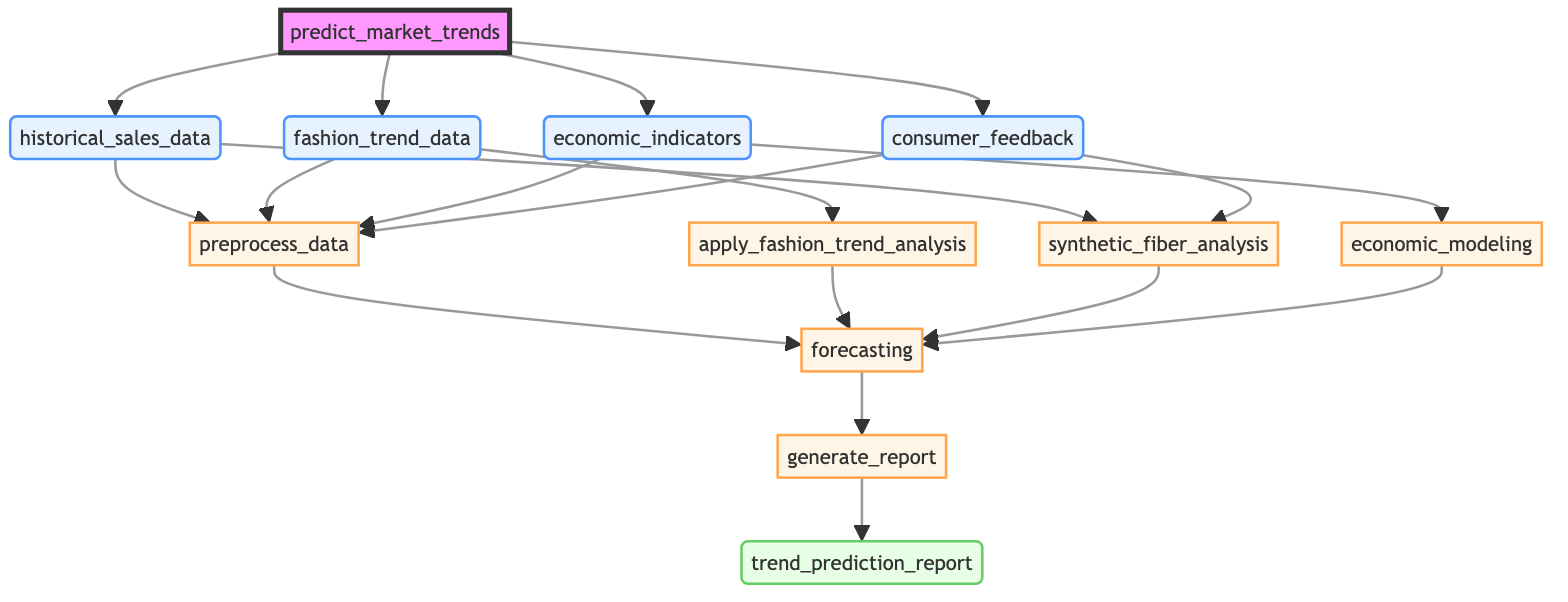What is the function name in this diagram? The function name is represented at the top of the diagram and labeled as "predict_market_trends."
Answer: predict_market_trends How many input parameters are there? By counting the nodes labeled as input parameters, there are four: "historical_sales_data," "fashion_trend_data," "economic_indicators," and "consumer_feedback."
Answer: 4 Which process step follows "preprocess_data"? The diagram shows arrows pointing from "preprocess_data" leading to the next step, which is "forecasting," after incorporating several analyses.
Answer: forecasting What is the output of the function? The output node at the bottom of the diagram is labeled as "trend_prediction_report," which indicates the result of the function.
Answer: trend_prediction_report Which process step relies on "economic_indicators"? The diagram indicates that "economic_modeling" is the process step that is directly dependent on "economic_indicators."
Answer: economic_modeling What are the dependencies of "forecasting"? The node labeled "forecasting" is dependent on the nodes "processed_data," "fashion_trend_analysis," "synthetic_fiber_analysis," and "economic_modeling."
Answer: processed_data, fashion_trend_analysis, synthetic_fiber_analysis, economic_modeling Which two input nodes are linked to "synthetic_fiber_analysis"? The arrows going into "synthetic_fiber_analysis" show that both "historical_sales_data" and "consumer_feedback" provide input to this analysis step.
Answer: historical_sales_data, consumer_feedback What is the purpose of the "generate_report" step? The "generate_report" step is to create a detailed report with visualizations based on the results produced by the "forecasting" step.
Answer: Create detailed report with visualizations What analysis is conducted using social media sentiment? The diagram indicates that "apply_fashion_trend_analysis" utilizes data from social media sentiment to analyze recent fashion trends.
Answer: apply_fashion_trend_analysis 